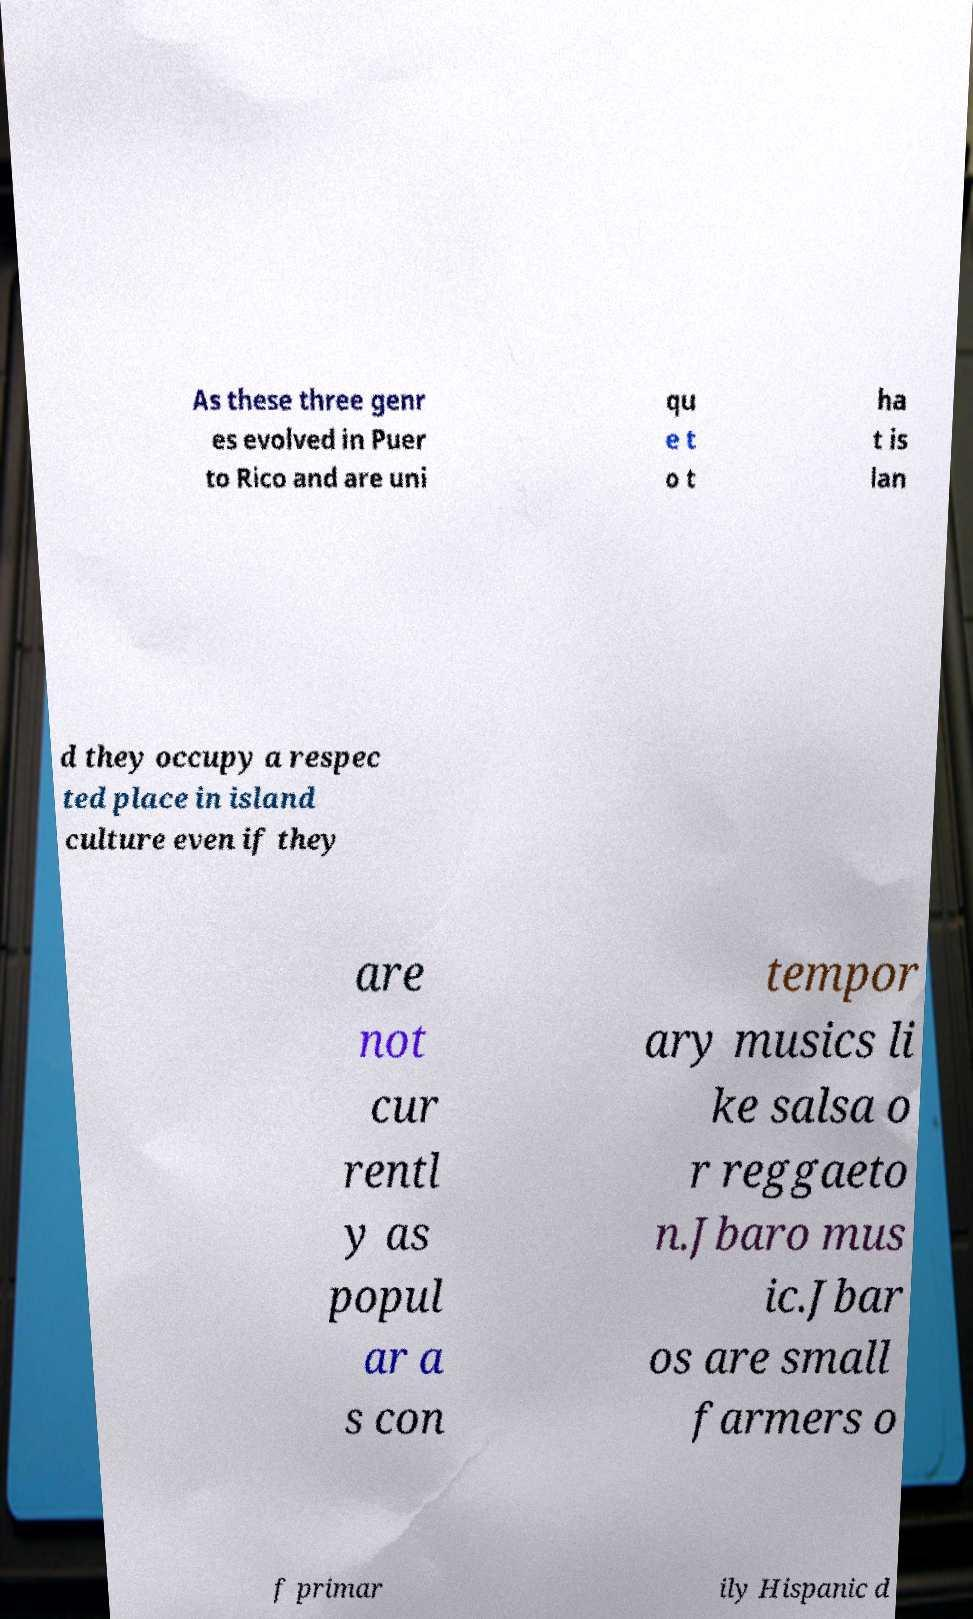What messages or text are displayed in this image? I need them in a readable, typed format. As these three genr es evolved in Puer to Rico and are uni qu e t o t ha t is lan d they occupy a respec ted place in island culture even if they are not cur rentl y as popul ar a s con tempor ary musics li ke salsa o r reggaeto n.Jbaro mus ic.Jbar os are small farmers o f primar ily Hispanic d 